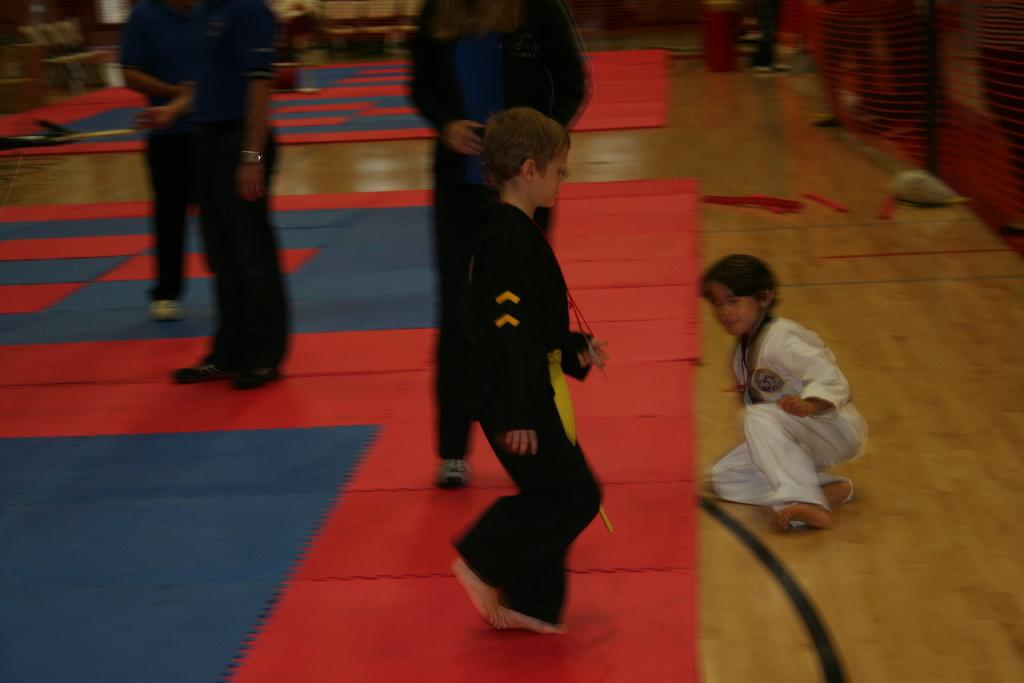How many people are in the image? There is a group of people in the image, but the exact number is not specified. What is the surface on which the people are standing? The people are standing on a carpet. What type of wire can be seen connecting the people in the image? There is no wire connecting the people in the image; they are simply standing on a carpet. 